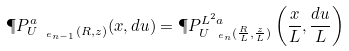Convert formula to latex. <formula><loc_0><loc_0><loc_500><loc_500>\P P ^ { a } _ { U _ { \ e _ { n - 1 } } ( R , z ) } ( x , d u ) = \P P ^ { L ^ { 2 } a } _ { U _ { \ e _ { n } } ( \frac { R } { L } , \frac { z } { L } ) } \left ( \frac { x } { L } , \frac { d u } { L } \right )</formula> 